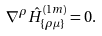<formula> <loc_0><loc_0><loc_500><loc_500>\nabla ^ { \rho } \hat { H } _ { \{ \rho \mu \} } ^ { ( 1 m ) } = 0 .</formula> 